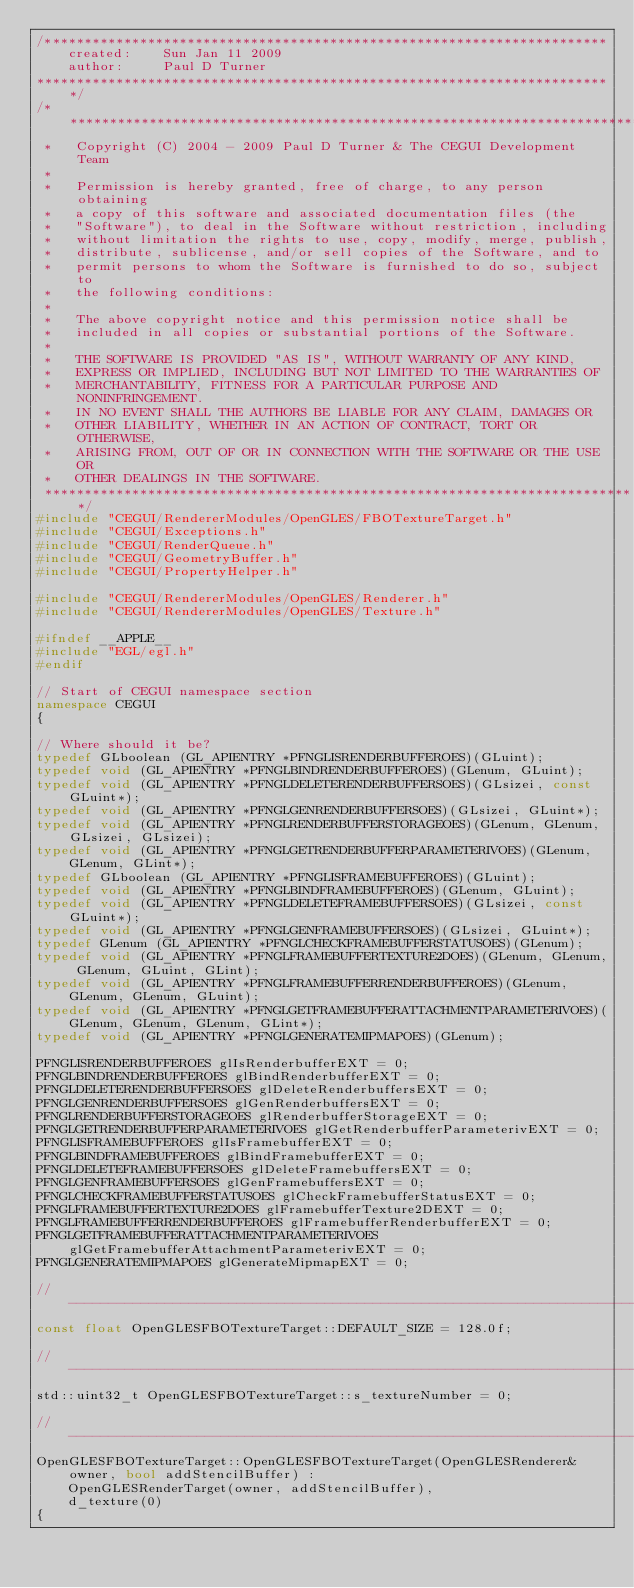Convert code to text. <code><loc_0><loc_0><loc_500><loc_500><_C++_>/***********************************************************************
    created:    Sun Jan 11 2009
    author:     Paul D Turner
*************************************************************************/
/***************************************************************************
 *   Copyright (C) 2004 - 2009 Paul D Turner & The CEGUI Development Team
 *
 *   Permission is hereby granted, free of charge, to any person obtaining
 *   a copy of this software and associated documentation files (the
 *   "Software"), to deal in the Software without restriction, including
 *   without limitation the rights to use, copy, modify, merge, publish,
 *   distribute, sublicense, and/or sell copies of the Software, and to
 *   permit persons to whom the Software is furnished to do so, subject to
 *   the following conditions:
 *
 *   The above copyright notice and this permission notice shall be
 *   included in all copies or substantial portions of the Software.
 *
 *   THE SOFTWARE IS PROVIDED "AS IS", WITHOUT WARRANTY OF ANY KIND,
 *   EXPRESS OR IMPLIED, INCLUDING BUT NOT LIMITED TO THE WARRANTIES OF
 *   MERCHANTABILITY, FITNESS FOR A PARTICULAR PURPOSE AND NONINFRINGEMENT.
 *   IN NO EVENT SHALL THE AUTHORS BE LIABLE FOR ANY CLAIM, DAMAGES OR
 *   OTHER LIABILITY, WHETHER IN AN ACTION OF CONTRACT, TORT OR OTHERWISE,
 *   ARISING FROM, OUT OF OR IN CONNECTION WITH THE SOFTWARE OR THE USE OR
 *   OTHER DEALINGS IN THE SOFTWARE.
 ***************************************************************************/
#include "CEGUI/RendererModules/OpenGLES/FBOTextureTarget.h"
#include "CEGUI/Exceptions.h"
#include "CEGUI/RenderQueue.h"
#include "CEGUI/GeometryBuffer.h"
#include "CEGUI/PropertyHelper.h"

#include "CEGUI/RendererModules/OpenGLES/Renderer.h"
#include "CEGUI/RendererModules/OpenGLES/Texture.h"

#ifndef __APPLE__
#include "EGL/egl.h"
#endif

// Start of CEGUI namespace section
namespace CEGUI
{

// Where should it be?
typedef GLboolean (GL_APIENTRY *PFNGLISRENDERBUFFEROES)(GLuint);
typedef void (GL_APIENTRY *PFNGLBINDRENDERBUFFEROES)(GLenum, GLuint);
typedef void (GL_APIENTRY *PFNGLDELETERENDERBUFFERSOES)(GLsizei, const GLuint*);
typedef void (GL_APIENTRY *PFNGLGENRENDERBUFFERSOES)(GLsizei, GLuint*);
typedef void (GL_APIENTRY *PFNGLRENDERBUFFERSTORAGEOES)(GLenum, GLenum, GLsizei, GLsizei);
typedef void (GL_APIENTRY *PFNGLGETRENDERBUFFERPARAMETERIVOES)(GLenum, GLenum, GLint*);
typedef GLboolean (GL_APIENTRY *PFNGLISFRAMEBUFFEROES)(GLuint);
typedef void (GL_APIENTRY *PFNGLBINDFRAMEBUFFEROES)(GLenum, GLuint);
typedef void (GL_APIENTRY *PFNGLDELETEFRAMEBUFFERSOES)(GLsizei, const GLuint*);
typedef void (GL_APIENTRY *PFNGLGENFRAMEBUFFERSOES)(GLsizei, GLuint*);
typedef GLenum (GL_APIENTRY *PFNGLCHECKFRAMEBUFFERSTATUSOES)(GLenum);
typedef void (GL_APIENTRY *PFNGLFRAMEBUFFERTEXTURE2DOES)(GLenum, GLenum, GLenum, GLuint, GLint);
typedef void (GL_APIENTRY *PFNGLFRAMEBUFFERRENDERBUFFEROES)(GLenum, GLenum, GLenum, GLuint);
typedef void (GL_APIENTRY *PFNGLGETFRAMEBUFFERATTACHMENTPARAMETERIVOES)(GLenum, GLenum, GLenum, GLint*);
typedef void (GL_APIENTRY *PFNGLGENERATEMIPMAPOES)(GLenum);

PFNGLISRENDERBUFFEROES glIsRenderbufferEXT = 0;
PFNGLBINDRENDERBUFFEROES glBindRenderbufferEXT = 0;
PFNGLDELETERENDERBUFFERSOES glDeleteRenderbuffersEXT = 0;
PFNGLGENRENDERBUFFERSOES glGenRenderbuffersEXT = 0;
PFNGLRENDERBUFFERSTORAGEOES glRenderbufferStorageEXT = 0;
PFNGLGETRENDERBUFFERPARAMETERIVOES glGetRenderbufferParameterivEXT = 0;
PFNGLISFRAMEBUFFEROES glIsFramebufferEXT = 0;
PFNGLBINDFRAMEBUFFEROES glBindFramebufferEXT = 0;
PFNGLDELETEFRAMEBUFFERSOES glDeleteFramebuffersEXT = 0;
PFNGLGENFRAMEBUFFERSOES glGenFramebuffersEXT = 0;
PFNGLCHECKFRAMEBUFFERSTATUSOES glCheckFramebufferStatusEXT = 0;
PFNGLFRAMEBUFFERTEXTURE2DOES glFramebufferTexture2DEXT = 0;
PFNGLFRAMEBUFFERRENDERBUFFEROES glFramebufferRenderbufferEXT = 0;
PFNGLGETFRAMEBUFFERATTACHMENTPARAMETERIVOES glGetFramebufferAttachmentParameterivEXT = 0;
PFNGLGENERATEMIPMAPOES glGenerateMipmapEXT = 0;	
	
//----------------------------------------------------------------------------//
const float OpenGLESFBOTextureTarget::DEFAULT_SIZE = 128.0f;

//----------------------------------------------------------------------------//
std::uint32_t OpenGLESFBOTextureTarget::s_textureNumber = 0;

//----------------------------------------------------------------------------//
OpenGLESFBOTextureTarget::OpenGLESFBOTextureTarget(OpenGLESRenderer& owner, bool addStencilBuffer) :
    OpenGLESRenderTarget(owner, addStencilBuffer),
    d_texture(0)
{</code> 